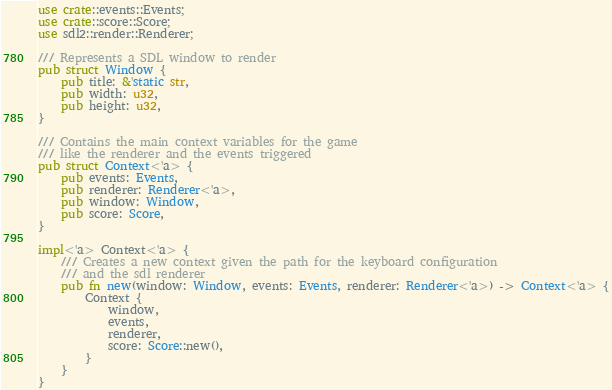<code> <loc_0><loc_0><loc_500><loc_500><_Rust_>use crate::events::Events;
use crate::score::Score;
use sdl2::render::Renderer;

/// Represents a SDL window to render
pub struct Window {
    pub title: &'static str,
    pub width: u32,
    pub height: u32,
}

/// Contains the main context variables for the game
/// like the renderer and the events triggered
pub struct Context<'a> {
    pub events: Events,
    pub renderer: Renderer<'a>,
    pub window: Window,
    pub score: Score,
}

impl<'a> Context<'a> {
    /// Creates a new context given the path for the keyboard configuration
    /// and the sdl renderer
    pub fn new(window: Window, events: Events, renderer: Renderer<'a>) -> Context<'a> {
        Context {
            window,
            events,
            renderer,
            score: Score::new(),
        }
    }
}
</code> 